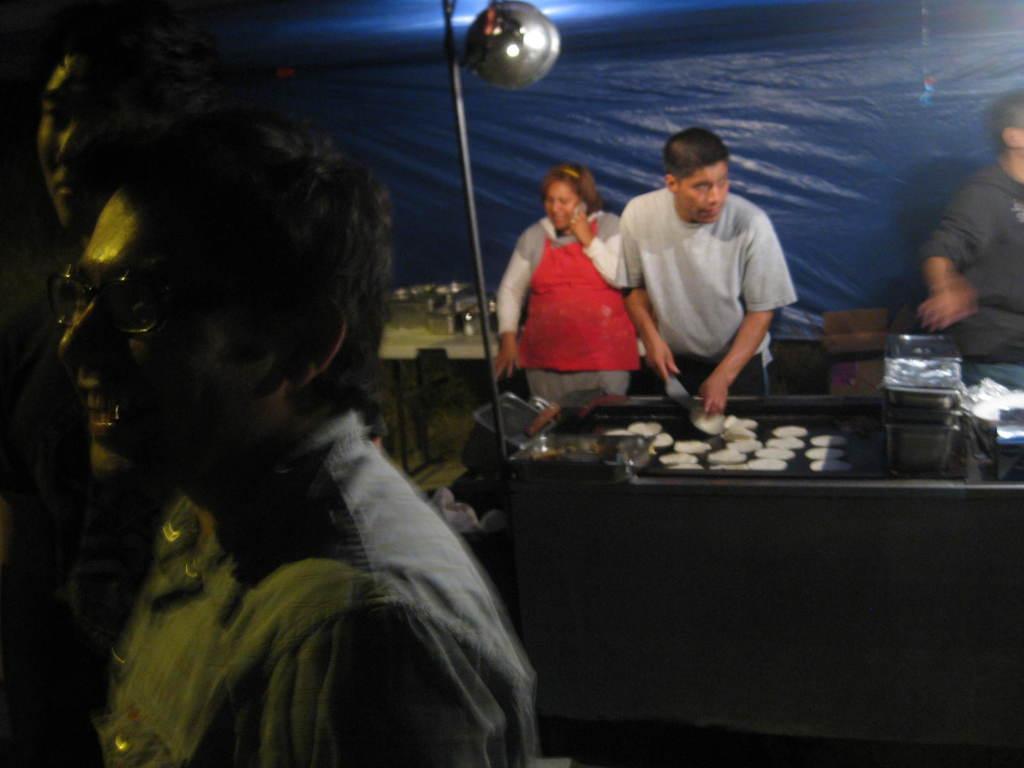In one or two sentences, can you explain what this image depicts? In this image there are two persons with a smile on their face, behind them there is a person holding a knife, is chopping some food items in front of him, behind the person there is a woman speaking on a mobile, behind the women there are a few utensils placed on a table, behind the table there is a tent. 